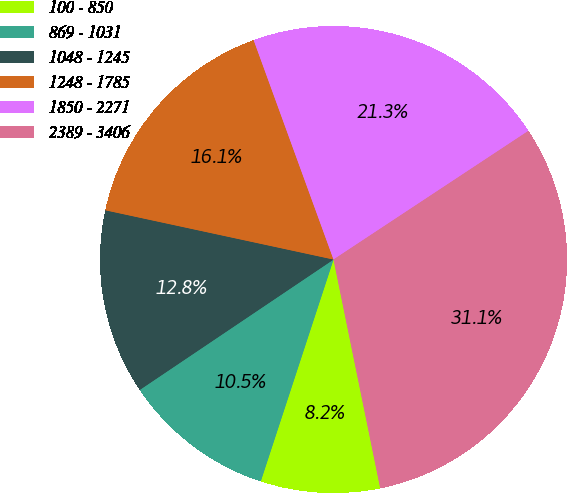Convert chart. <chart><loc_0><loc_0><loc_500><loc_500><pie_chart><fcel>100 - 850<fcel>869 - 1031<fcel>1048 - 1245<fcel>1248 - 1785<fcel>1850 - 2271<fcel>2389 - 3406<nl><fcel>8.25%<fcel>10.53%<fcel>12.81%<fcel>16.06%<fcel>21.27%<fcel>31.08%<nl></chart> 